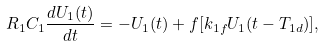<formula> <loc_0><loc_0><loc_500><loc_500>R _ { 1 } C _ { 1 } \frac { d U _ { 1 } ( t ) } { d t } = - U _ { 1 } ( t ) + f [ k _ { 1 f } U _ { 1 } ( t - T _ { 1 d } ) ] ,</formula> 